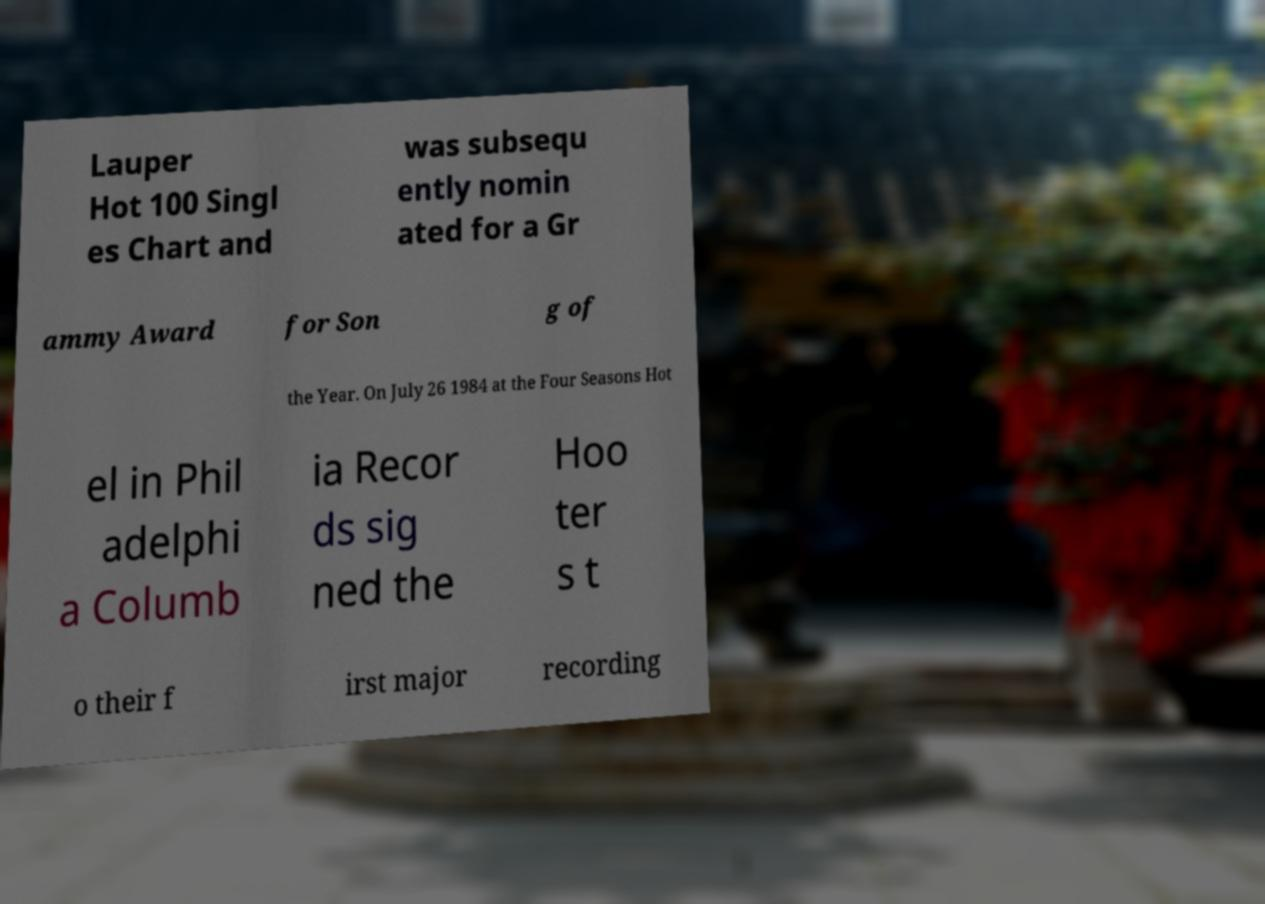Please identify and transcribe the text found in this image. Lauper Hot 100 Singl es Chart and was subsequ ently nomin ated for a Gr ammy Award for Son g of the Year. On July 26 1984 at the Four Seasons Hot el in Phil adelphi a Columb ia Recor ds sig ned the Hoo ter s t o their f irst major recording 